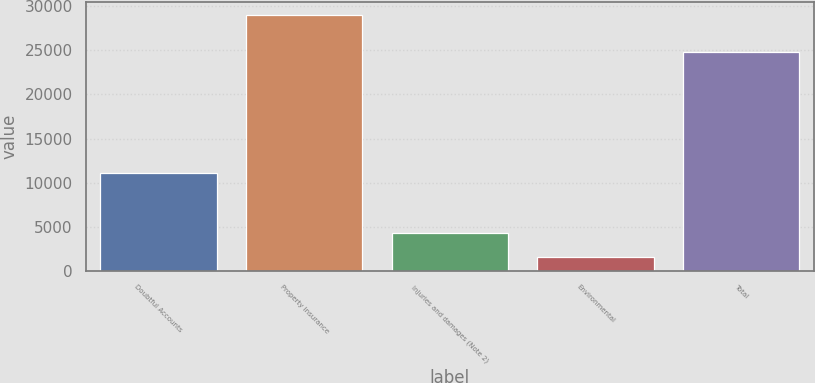Convert chart to OTSL. <chart><loc_0><loc_0><loc_500><loc_500><bar_chart><fcel>Doubtful Accounts<fcel>Property insurance<fcel>Injuries and damages (Note 2)<fcel>Environmental<fcel>Total<nl><fcel>11039<fcel>29027<fcel>4311.2<fcel>1565<fcel>24849<nl></chart> 